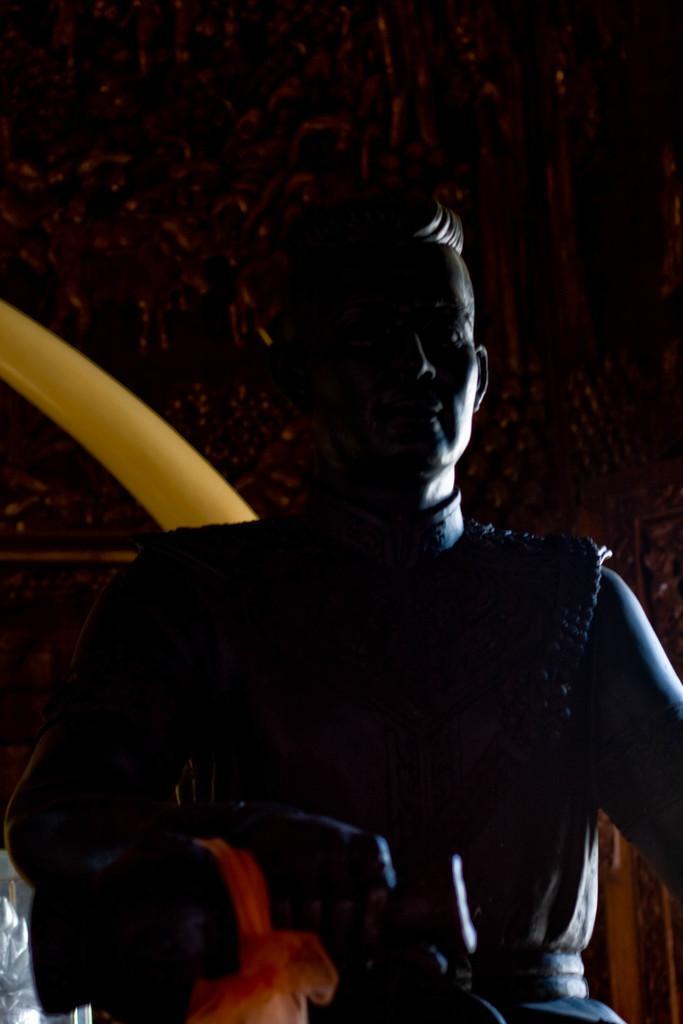Describe this image in one or two sentences. In this image, we can see a statue. In the background, we can see the wall with some sculptures. We can also see a yellow colored object. We can see an object on the bottom left. 